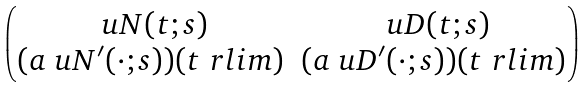<formula> <loc_0><loc_0><loc_500><loc_500>\begin{pmatrix} \ u N ( t ; s ) & \ u D ( t ; s ) \\ ( a \ u N ^ { \prime } ( \cdot ; s ) ) ( t \ r l i m ) & ( a \ u D ^ { \prime } ( \cdot ; s ) ) ( t \ r l i m ) \end{pmatrix}</formula> 